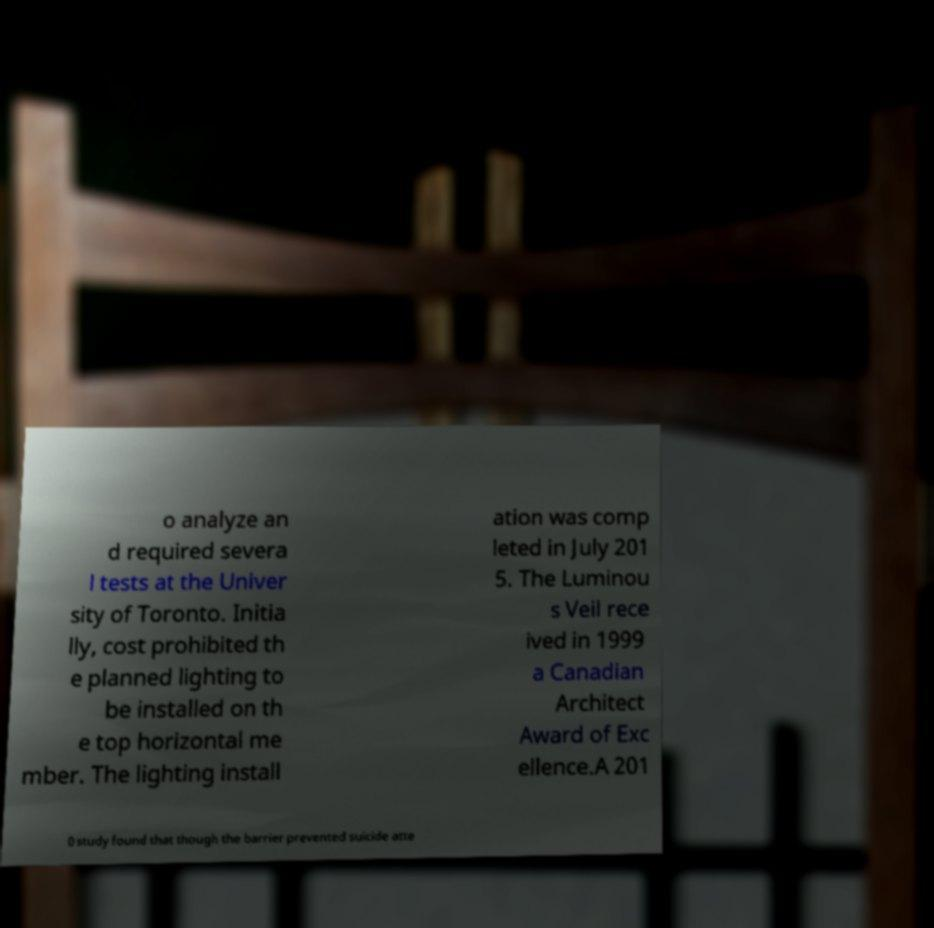I need the written content from this picture converted into text. Can you do that? o analyze an d required severa l tests at the Univer sity of Toronto. Initia lly, cost prohibited th e planned lighting to be installed on th e top horizontal me mber. The lighting install ation was comp leted in July 201 5. The Luminou s Veil rece ived in 1999 a Canadian Architect Award of Exc ellence.A 201 0 study found that though the barrier prevented suicide atte 